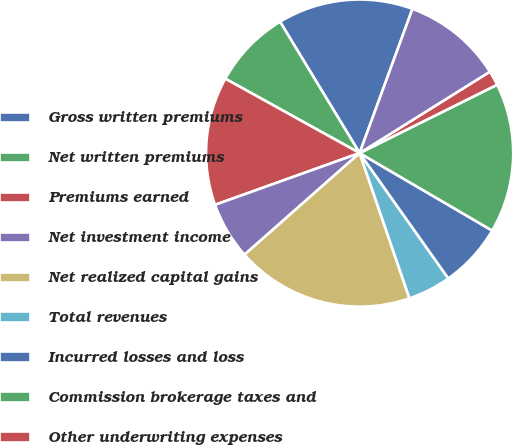Convert chart to OTSL. <chart><loc_0><loc_0><loc_500><loc_500><pie_chart><fcel>Gross written premiums<fcel>Net written premiums<fcel>Premiums earned<fcel>Net investment income<fcel>Net realized capital gains<fcel>Total revenues<fcel>Incurred losses and loss<fcel>Commission brokerage taxes and<fcel>Other underwriting expenses<fcel>Corporate expenses<nl><fcel>14.26%<fcel>8.28%<fcel>13.52%<fcel>6.04%<fcel>18.75%<fcel>4.54%<fcel>6.78%<fcel>15.76%<fcel>1.55%<fcel>10.52%<nl></chart> 